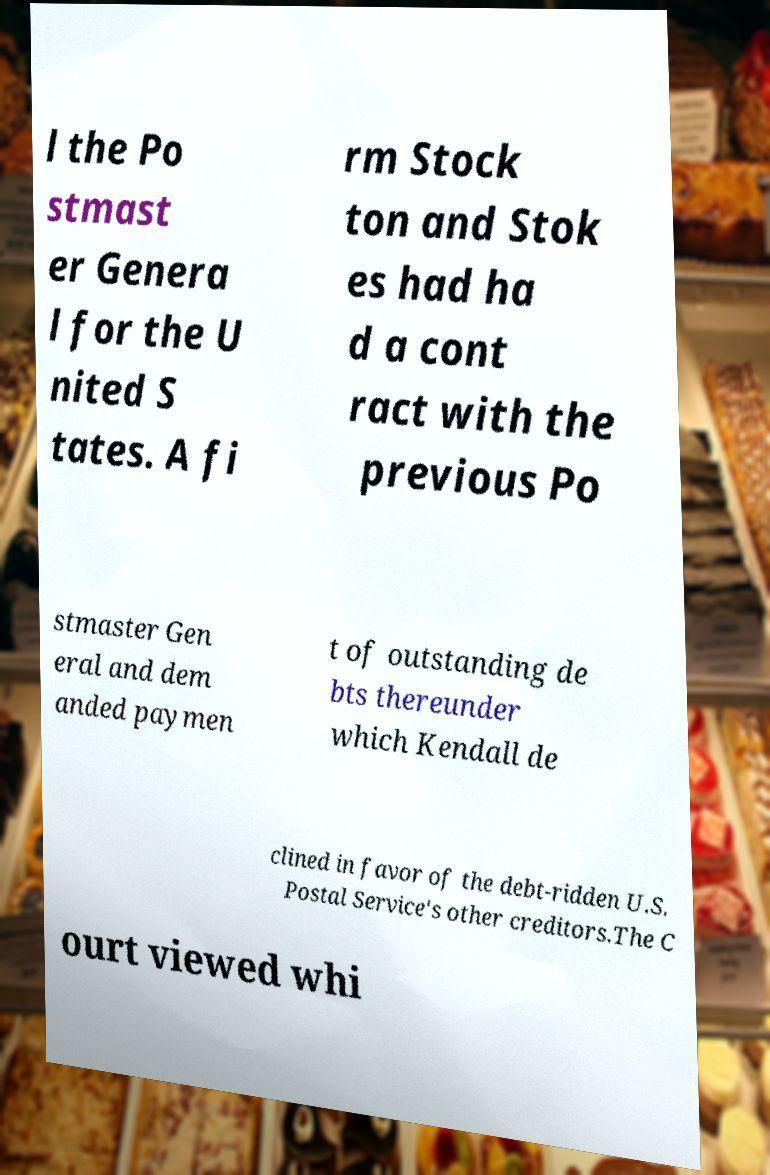There's text embedded in this image that I need extracted. Can you transcribe it verbatim? l the Po stmast er Genera l for the U nited S tates. A fi rm Stock ton and Stok es had ha d a cont ract with the previous Po stmaster Gen eral and dem anded paymen t of outstanding de bts thereunder which Kendall de clined in favor of the debt-ridden U.S. Postal Service's other creditors.The C ourt viewed whi 